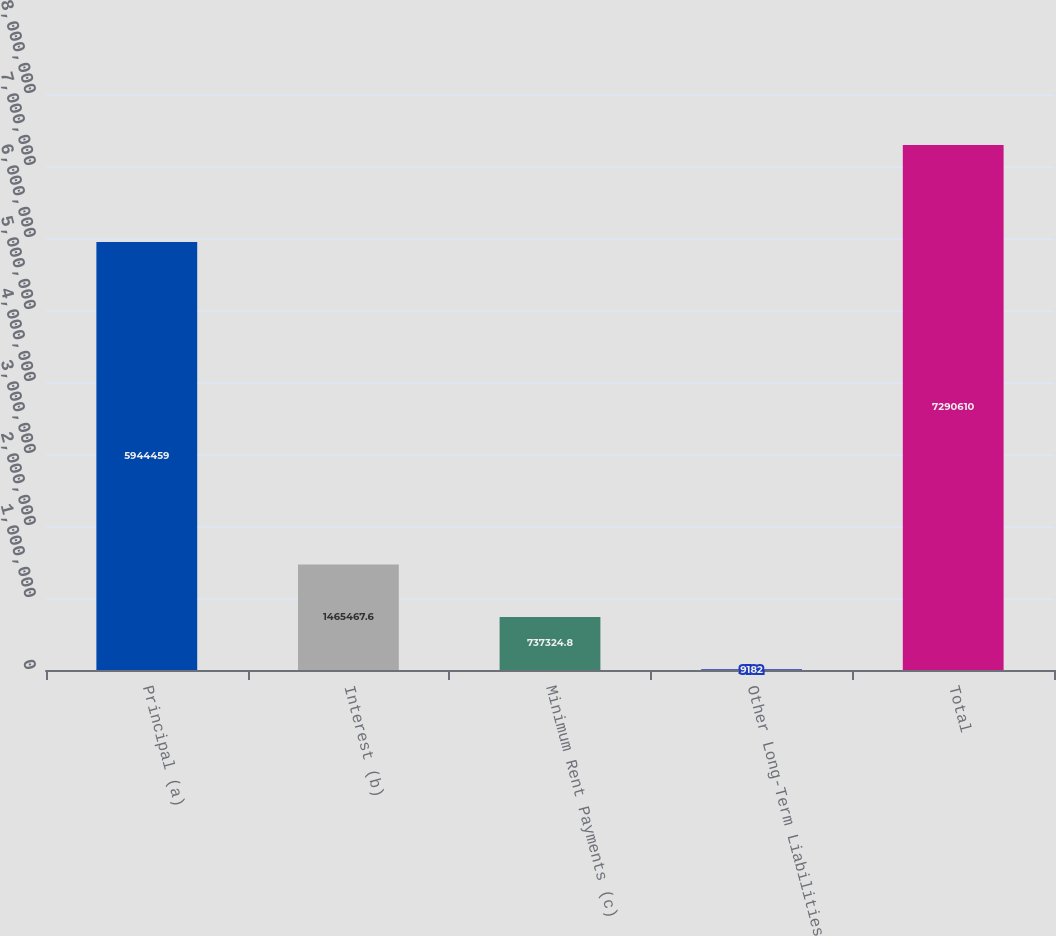Convert chart to OTSL. <chart><loc_0><loc_0><loc_500><loc_500><bar_chart><fcel>Principal (a)<fcel>Interest (b)<fcel>Minimum Rent Payments (c)<fcel>Other Long-Term Liabilities<fcel>Total<nl><fcel>5.94446e+06<fcel>1.46547e+06<fcel>737325<fcel>9182<fcel>7.29061e+06<nl></chart> 